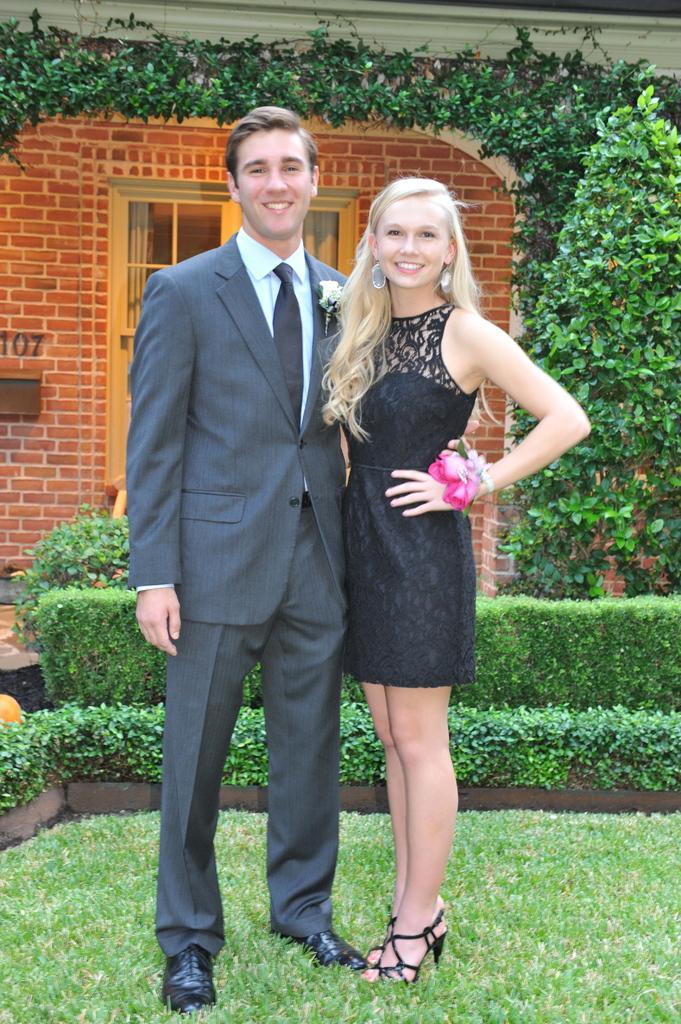How would you summarize this image in a sentence or two? In this picture there is a man who is wearing suit, trouser and shoe. Beside him there is a woman who is wearing black dress, band and sandal. Both of them are smiling. They are standing on the grass. Behind them I can see the plants and trees. In the background there was a building. On the left there is a door. 